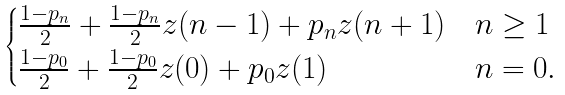<formula> <loc_0><loc_0><loc_500><loc_500>\begin{cases} \frac { 1 - p _ { n } } { 2 } + \frac { 1 - p _ { n } } { 2 } z ( n - 1 ) + p _ { n } z ( n + 1 ) & n \geq 1 \\ \frac { 1 - p _ { 0 } } { 2 } + \frac { 1 - p _ { 0 } } { 2 } z ( 0 ) + p _ { 0 } z ( 1 ) & n = 0 . \\ \end{cases}</formula> 